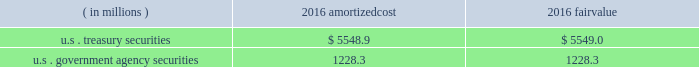Each clearing firm is required to deposit and maintain balances in the form of cash , u.s .
Government securities , certain foreign government securities , bank letters of credit or other approved investments to satisfy performance bond and guaranty fund requirements .
All non-cash deposits are marked-to-market and haircut on a daily basis .
Securities deposited by the clearing firms are not reflected in the consolidated financial statements and the clearing house does not earn any interest on these deposits .
These balances may fluctuate significantly over time due to investment choices available to clearing firms and changes in the amount of contributions required .
In addition , the rules and regulations of cbot require that collateral be provided for delivery of physical commodities , maintenance of capital requirements and deposits on pending arbitration matters .
To satisfy these requirements , clearing firms that have accounts that trade certain cbot products have deposited cash , u.s .
Treasury securities or letters of credit .
The clearing house marks-to-market open positions at least once a day ( twice a day for futures and options contracts ) , and require payment from clearing firms whose positions have lost value and make payments to clearing firms whose positions have gained value .
The clearing house has the capability to mark-to-market more frequently as market conditions warrant .
Under the extremely unlikely scenario of simultaneous default by every clearing firm who has open positions with unrealized losses , the maximum exposure related to positions other than credit default and interest rate swap contracts would be one half day of changes in fair value of all open positions , before considering the clearing houses 2019 ability to access defaulting clearing firms 2019 collateral deposits .
For cleared credit default swap and interest rate swap contracts , the maximum exposure related to cme 2019s guarantee would be one full day of changes in fair value of all open positions , before considering cme 2019s ability to access defaulting clearing firms 2019 collateral .
During 2017 , the clearing house transferred an average of approximately $ 2.4 billion a day through the clearing system for settlement from clearing firms whose positions had lost value to clearing firms whose positions had gained value .
The clearing house reduces the guarantee exposure through initial and maintenance performance bond requirements and mandatory guaranty fund contributions .
The company believes that the guarantee liability is immaterial and therefore has not recorded any liability at december 31 , 2017 .
At december 31 , 2016 , performance bond and guaranty fund contribution assets on the consolidated balance sheets included cash as well as u.s .
Treasury and u.s .
Government agency securities with maturity dates of 90 days or less .
The u.s .
Treasury and u.s .
Government agency securities were purchased by cme , at its discretion , using cash collateral .
The benefits , including interest earned , and risks of ownership accrue to cme .
Interest earned is included in investment income on the consolidated statements of income .
There were no u.s .
Treasury and u.s .
Government agency securities held at december 31 , 2017 .
The amortized cost and fair value of these securities at december 31 , 2016 were as follows : ( in millions ) amortized .
Cme has been designated as a systemically important financial market utility by the financial stability oversight council and maintains a cash account at the federal reserve bank of chicago .
At december 31 , 2017 and december 31 , 2016 , cme maintained $ 34.2 billion and $ 6.2 billion , respectively , within the cash account at the federal reserve bank of chicago .
Clearing firms , at their option , may instruct cme to deposit the cash held by cme into one of the ief programs .
The total principal in the ief programs was $ 1.1 billion at december 31 , 2017 and $ 6.8 billion at december 31 .
Hat was total amount of cash held by the federal reserve bank of chicago on behalf of the cme , including cash accounts and ief programs on december 31st , 2017? 
Computations: (34.2 + 1.1)
Answer: 35.3. 